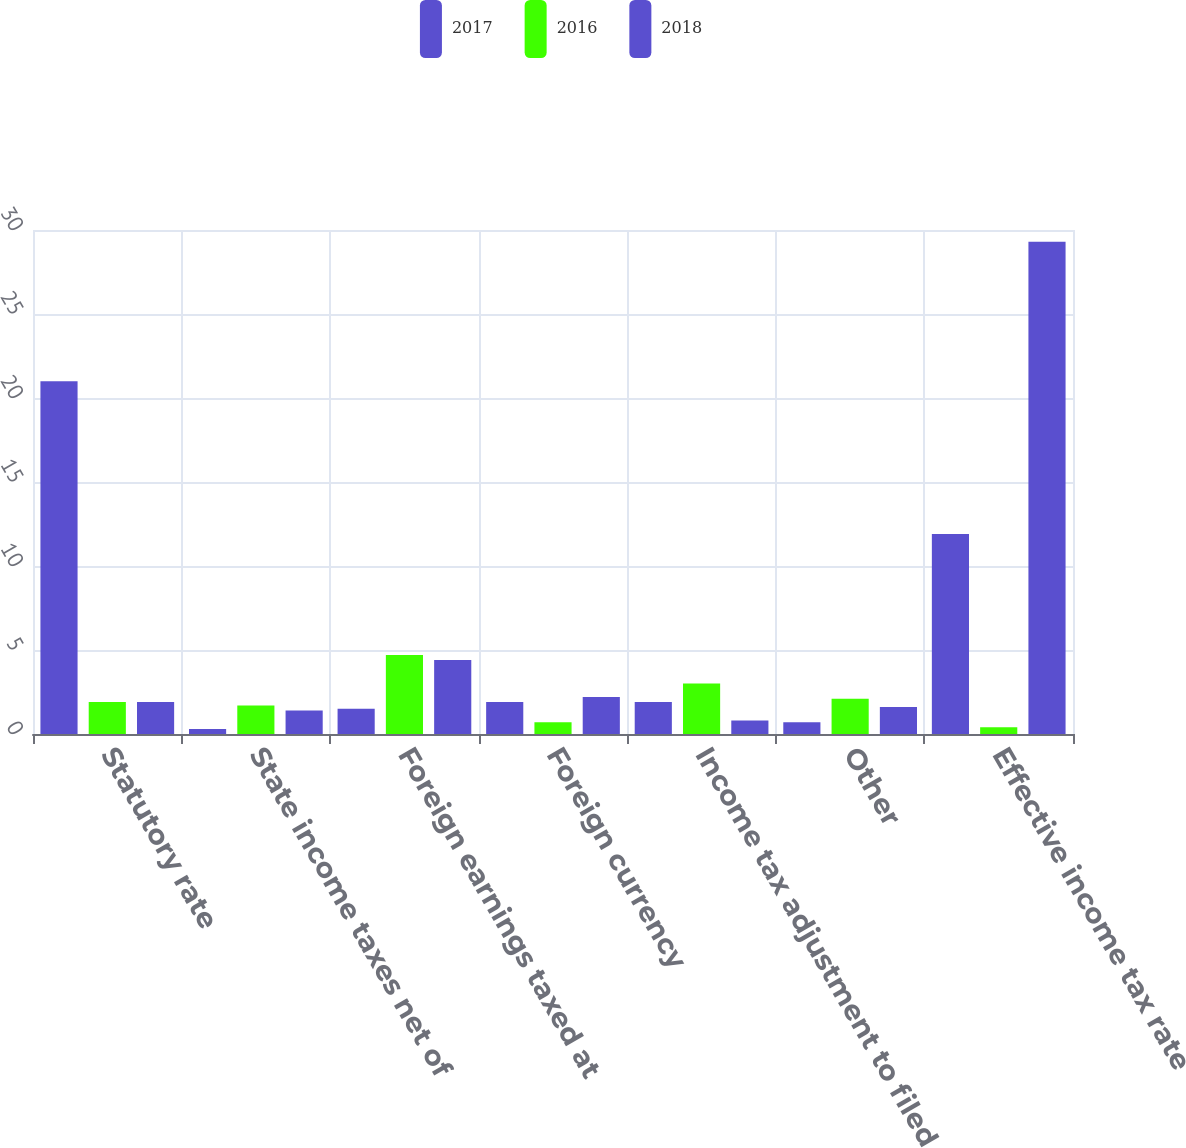<chart> <loc_0><loc_0><loc_500><loc_500><stacked_bar_chart><ecel><fcel>Statutory rate<fcel>State income taxes net of<fcel>Foreign earnings taxed at<fcel>Foreign currency<fcel>Income tax adjustment to filed<fcel>Other<fcel>Effective income tax rate<nl><fcel>2017<fcel>21<fcel>0.3<fcel>1.5<fcel>1.9<fcel>1.9<fcel>0.7<fcel>11.9<nl><fcel>2016<fcel>1.9<fcel>1.7<fcel>4.7<fcel>0.7<fcel>3<fcel>2.1<fcel>0.4<nl><fcel>2018<fcel>1.9<fcel>1.4<fcel>4.4<fcel>2.2<fcel>0.8<fcel>1.6<fcel>29.3<nl></chart> 